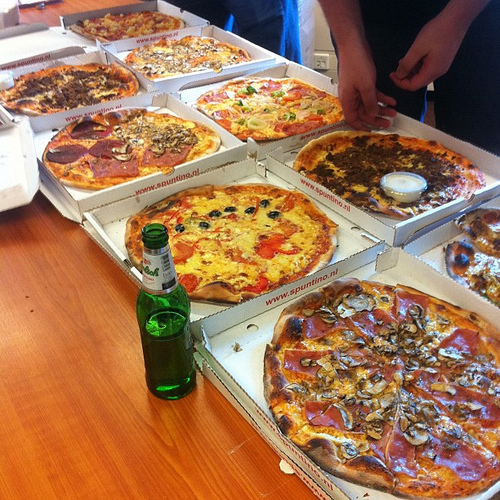What is in the box to the right of the ham? The box to the right of the ham contains pizza. 